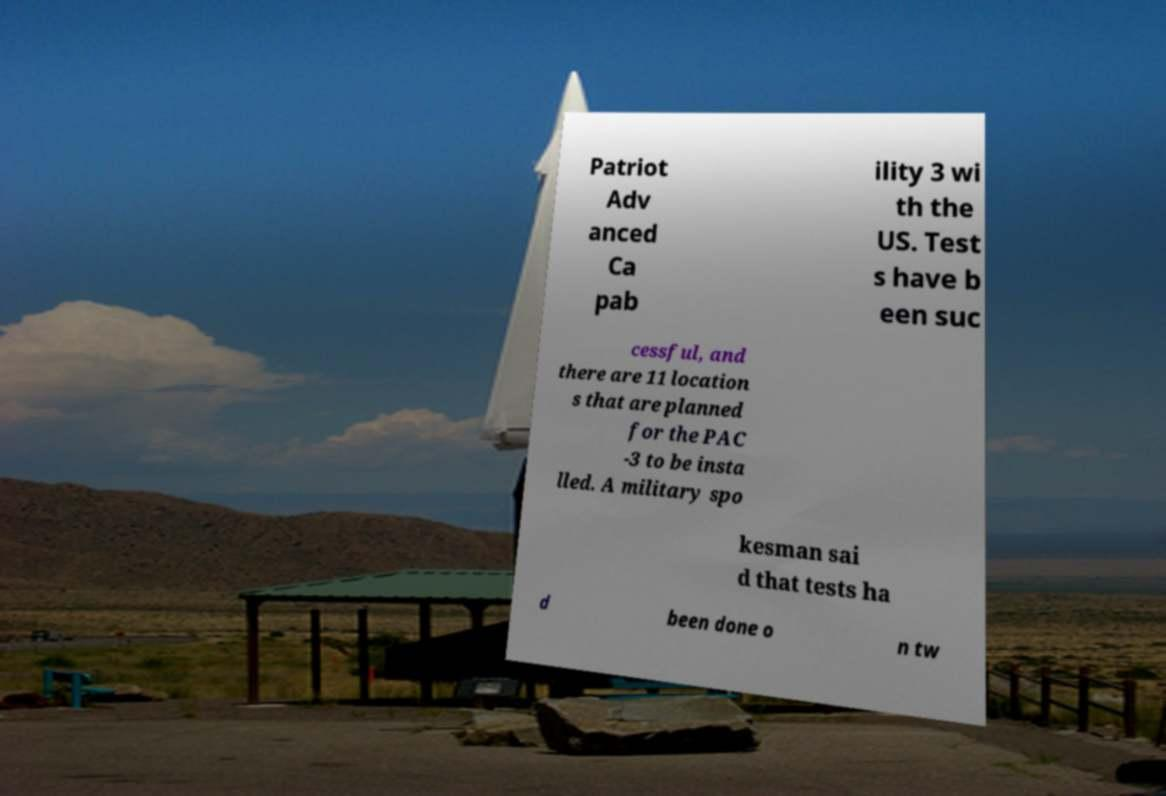I need the written content from this picture converted into text. Can you do that? Patriot Adv anced Ca pab ility 3 wi th the US. Test s have b een suc cessful, and there are 11 location s that are planned for the PAC -3 to be insta lled. A military spo kesman sai d that tests ha d been done o n tw 